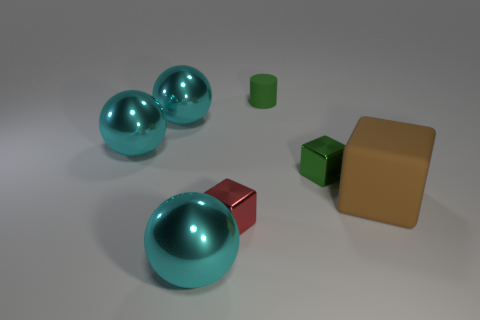There is a small green thing that is the same material as the large block; what is its shape?
Keep it short and to the point. Cylinder. How many green rubber cylinders are on the left side of the tiny metal thing on the left side of the green metallic object?
Ensure brevity in your answer.  0. What number of things are both on the left side of the brown object and on the right side of the cylinder?
Your answer should be compact. 1. How many other objects are there of the same material as the large block?
Provide a succinct answer. 1. There is a big object that is on the right side of the sphere in front of the large cube; what is its color?
Provide a succinct answer. Brown. There is a metal block behind the brown object; does it have the same color as the tiny cylinder?
Your answer should be compact. Yes. Do the brown rubber thing and the green rubber cylinder have the same size?
Provide a succinct answer. No. There is a rubber object that is the same size as the red shiny cube; what shape is it?
Provide a short and direct response. Cylinder. There is a metallic cube in front of the brown thing; does it have the same size as the green metal cube?
Your answer should be compact. Yes. There is another cube that is the same size as the red shiny block; what is its material?
Make the answer very short. Metal. 